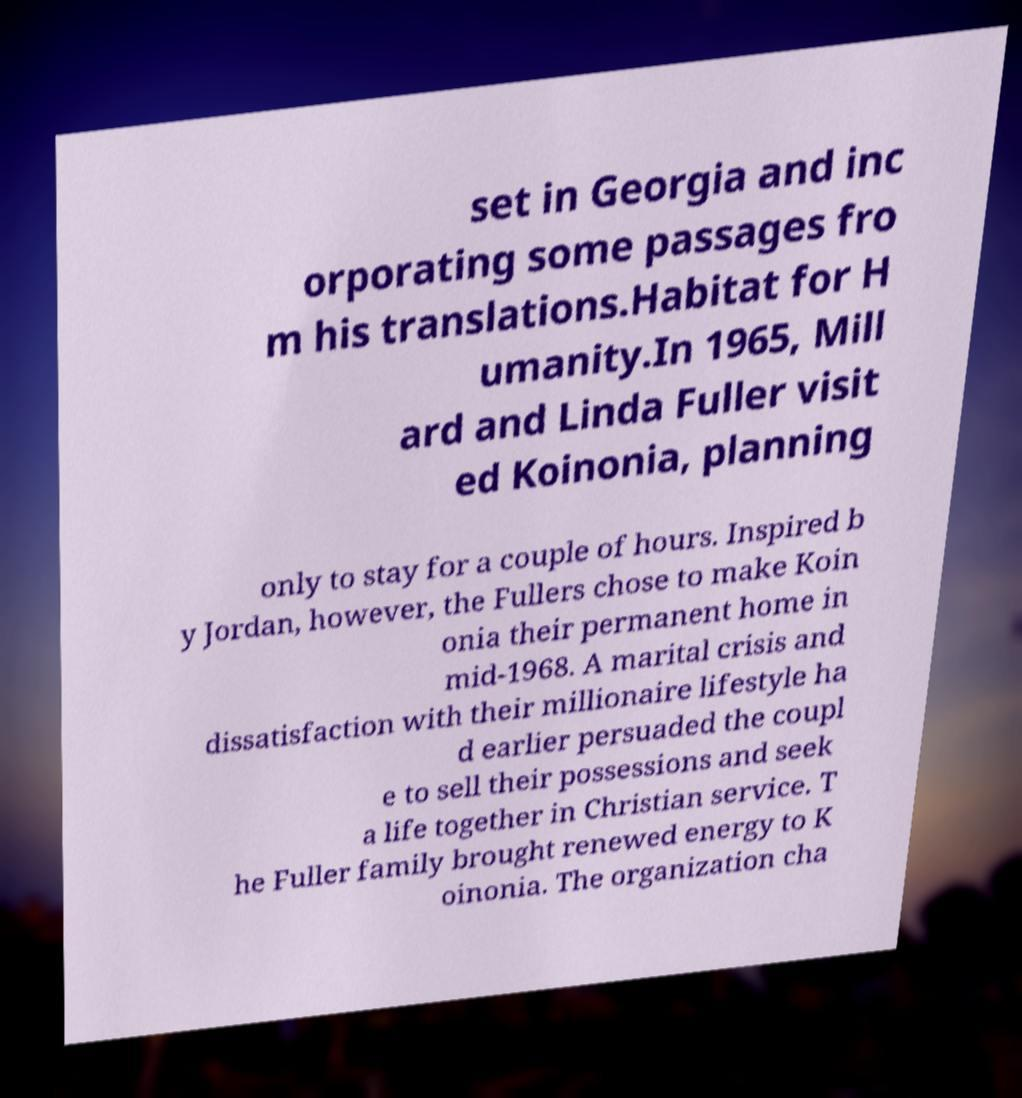Could you extract and type out the text from this image? set in Georgia and inc orporating some passages fro m his translations.Habitat for H umanity.In 1965, Mill ard and Linda Fuller visit ed Koinonia, planning only to stay for a couple of hours. Inspired b y Jordan, however, the Fullers chose to make Koin onia their permanent home in mid-1968. A marital crisis and dissatisfaction with their millionaire lifestyle ha d earlier persuaded the coupl e to sell their possessions and seek a life together in Christian service. T he Fuller family brought renewed energy to K oinonia. The organization cha 